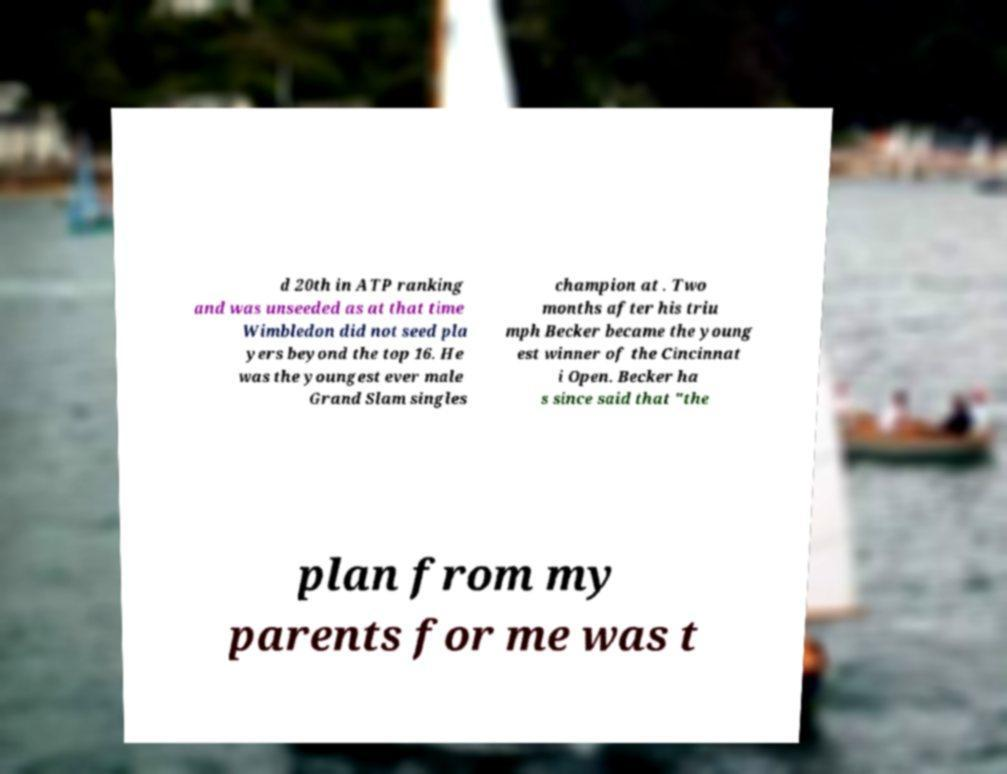Could you assist in decoding the text presented in this image and type it out clearly? d 20th in ATP ranking and was unseeded as at that time Wimbledon did not seed pla yers beyond the top 16. He was the youngest ever male Grand Slam singles champion at . Two months after his triu mph Becker became the young est winner of the Cincinnat i Open. Becker ha s since said that "the plan from my parents for me was t 